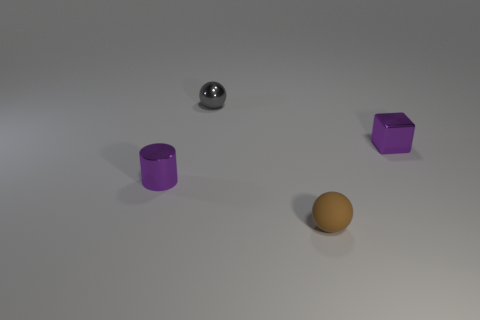Subtract all brown spheres. How many spheres are left? 1 Add 3 small yellow matte cubes. How many objects exist? 7 Subtract all cylinders. How many objects are left? 3 Subtract all blue cubes. Subtract all cyan spheres. How many cubes are left? 1 Subtract all purple cylinders. How many brown balls are left? 1 Subtract all cylinders. Subtract all small green shiny cylinders. How many objects are left? 3 Add 3 small shiny things. How many small shiny things are left? 6 Add 3 gray balls. How many gray balls exist? 4 Subtract 0 yellow spheres. How many objects are left? 4 